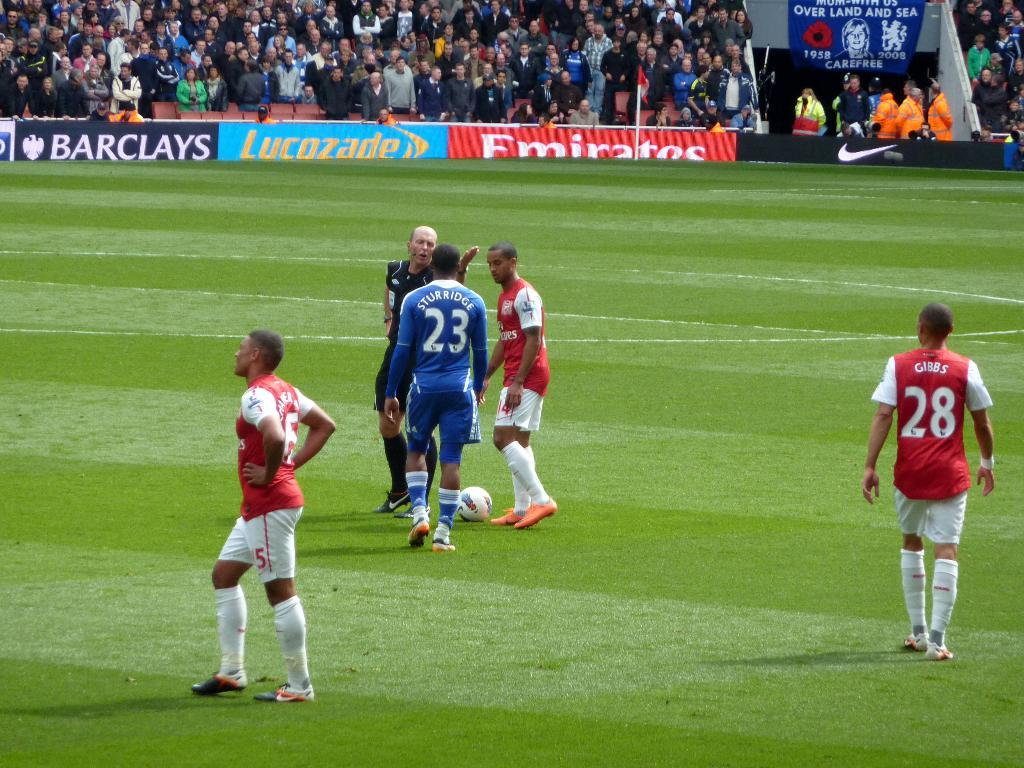<image>
Summarize the visual content of the image. A man in a blue uniform that says 23 on the back 